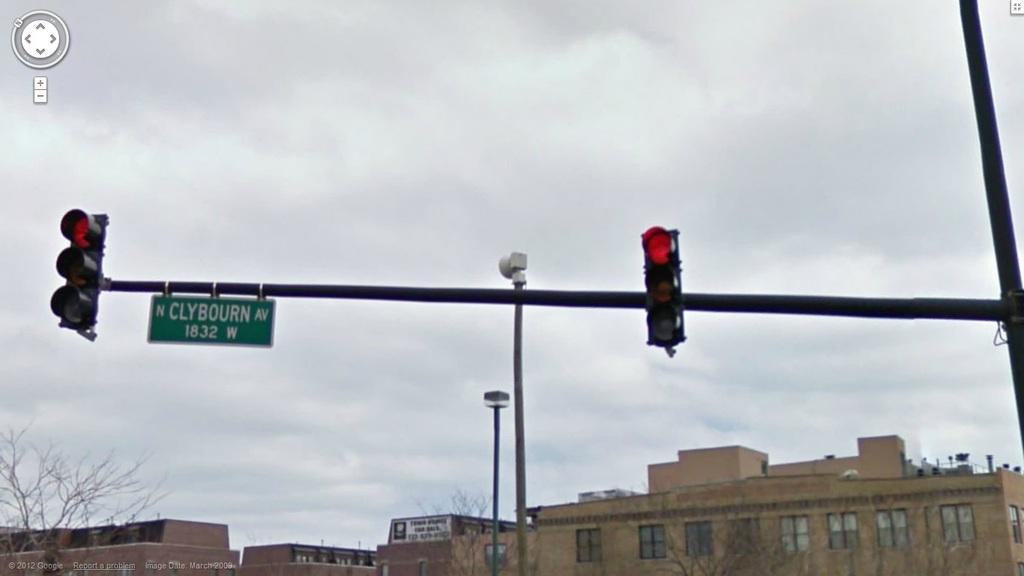Could you give a brief overview of what you see in this image? On the left side, there are signal lights and a sign board attached to a pole. On the right side, there are signal lights attached to the pole. In the background, there are two poles, there are buildings, trees and there are clouds in the sky. 